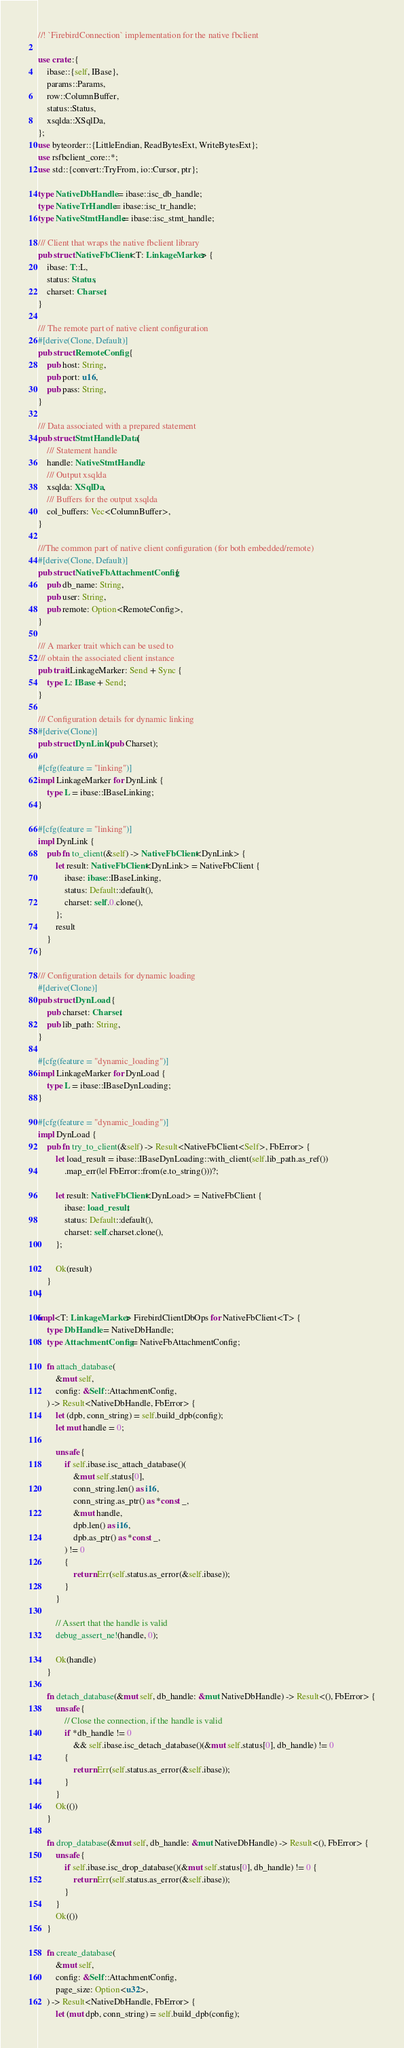Convert code to text. <code><loc_0><loc_0><loc_500><loc_500><_Rust_>//! `FirebirdConnection` implementation for the native fbclient

use crate::{
    ibase::{self, IBase},
    params::Params,
    row::ColumnBuffer,
    status::Status,
    xsqlda::XSqlDa,
};
use byteorder::{LittleEndian, ReadBytesExt, WriteBytesExt};
use rsfbclient_core::*;
use std::{convert::TryFrom, io::Cursor, ptr};

type NativeDbHandle = ibase::isc_db_handle;
type NativeTrHandle = ibase::isc_tr_handle;
type NativeStmtHandle = ibase::isc_stmt_handle;

/// Client that wraps the native fbclient library
pub struct NativeFbClient<T: LinkageMarker> {
    ibase: T::L,
    status: Status,
    charset: Charset,
}

/// The remote part of native client configuration
#[derive(Clone, Default)]
pub struct RemoteConfig {
    pub host: String,
    pub port: u16,
    pub pass: String,
}

/// Data associated with a prepared statement
pub struct StmtHandleData {
    /// Statement handle
    handle: NativeStmtHandle,
    /// Output xsqlda
    xsqlda: XSqlDa,
    /// Buffers for the output xsqlda
    col_buffers: Vec<ColumnBuffer>,
}

///The common part of native client configuration (for both embedded/remote)
#[derive(Clone, Default)]
pub struct NativeFbAttachmentConfig {
    pub db_name: String,
    pub user: String,
    pub remote: Option<RemoteConfig>,
}

/// A marker trait which can be used to
/// obtain the associated client instance
pub trait LinkageMarker: Send + Sync {
    type L: IBase + Send;
}

/// Configuration details for dynamic linking
#[derive(Clone)]
pub struct DynLink(pub Charset);

#[cfg(feature = "linking")]
impl LinkageMarker for DynLink {
    type L = ibase::IBaseLinking;
}

#[cfg(feature = "linking")]
impl DynLink {
    pub fn to_client(&self) -> NativeFbClient<DynLink> {
        let result: NativeFbClient<DynLink> = NativeFbClient {
            ibase: ibase::IBaseLinking,
            status: Default::default(),
            charset: self.0.clone(),
        };
        result
    }
}

/// Configuration details for dynamic loading
#[derive(Clone)]
pub struct DynLoad {
    pub charset: Charset,
    pub lib_path: String,
}

#[cfg(feature = "dynamic_loading")]
impl LinkageMarker for DynLoad {
    type L = ibase::IBaseDynLoading;
}

#[cfg(feature = "dynamic_loading")]
impl DynLoad {
    pub fn try_to_client(&self) -> Result<NativeFbClient<Self>, FbError> {
        let load_result = ibase::IBaseDynLoading::with_client(self.lib_path.as_ref())
            .map_err(|e| FbError::from(e.to_string()))?;

        let result: NativeFbClient<DynLoad> = NativeFbClient {
            ibase: load_result,
            status: Default::default(),
            charset: self.charset.clone(),
        };

        Ok(result)
    }
}

impl<T: LinkageMarker> FirebirdClientDbOps for NativeFbClient<T> {
    type DbHandle = NativeDbHandle;
    type AttachmentConfig = NativeFbAttachmentConfig;

    fn attach_database(
        &mut self,
        config: &Self::AttachmentConfig,
    ) -> Result<NativeDbHandle, FbError> {
        let (dpb, conn_string) = self.build_dpb(config);
        let mut handle = 0;

        unsafe {
            if self.ibase.isc_attach_database()(
                &mut self.status[0],
                conn_string.len() as i16,
                conn_string.as_ptr() as *const _,
                &mut handle,
                dpb.len() as i16,
                dpb.as_ptr() as *const _,
            ) != 0
            {
                return Err(self.status.as_error(&self.ibase));
            }
        }

        // Assert that the handle is valid
        debug_assert_ne!(handle, 0);

        Ok(handle)
    }

    fn detach_database(&mut self, db_handle: &mut NativeDbHandle) -> Result<(), FbError> {
        unsafe {
            // Close the connection, if the handle is valid
            if *db_handle != 0
                && self.ibase.isc_detach_database()(&mut self.status[0], db_handle) != 0
            {
                return Err(self.status.as_error(&self.ibase));
            }
        }
        Ok(())
    }

    fn drop_database(&mut self, db_handle: &mut NativeDbHandle) -> Result<(), FbError> {
        unsafe {
            if self.ibase.isc_drop_database()(&mut self.status[0], db_handle) != 0 {
                return Err(self.status.as_error(&self.ibase));
            }
        }
        Ok(())
    }

    fn create_database(
        &mut self,
        config: &Self::AttachmentConfig,
        page_size: Option<u32>,
    ) -> Result<NativeDbHandle, FbError> {
        let (mut dpb, conn_string) = self.build_dpb(config);</code> 